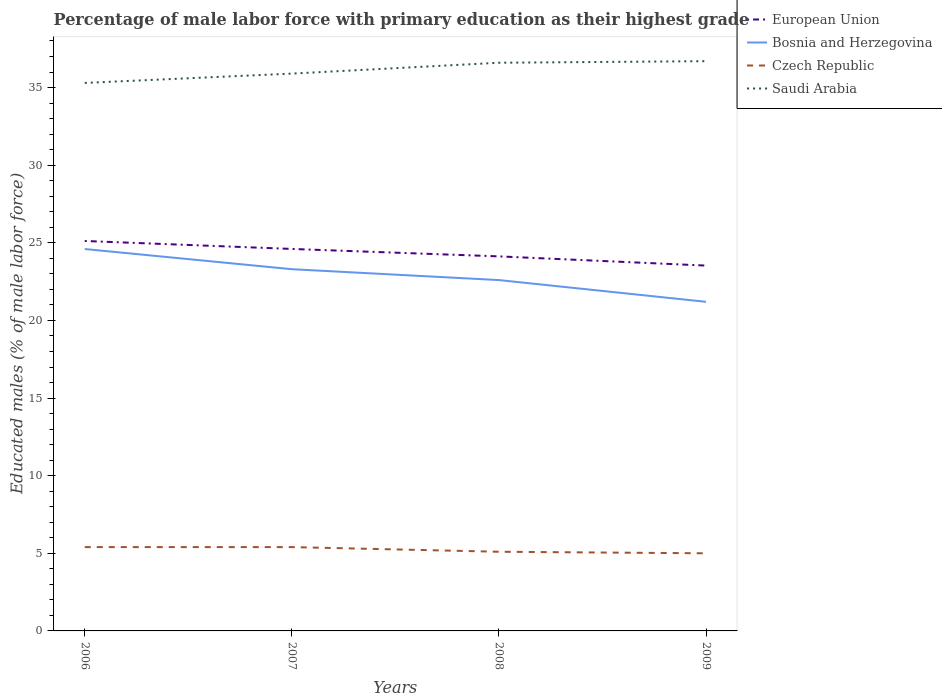How many different coloured lines are there?
Offer a terse response. 4. Across all years, what is the maximum percentage of male labor force with primary education in Bosnia and Herzegovina?
Ensure brevity in your answer.  21.2. In which year was the percentage of male labor force with primary education in European Union maximum?
Give a very brief answer. 2009. What is the total percentage of male labor force with primary education in Bosnia and Herzegovina in the graph?
Provide a short and direct response. 2.1. What is the difference between the highest and the second highest percentage of male labor force with primary education in European Union?
Offer a terse response. 1.59. What is the difference between the highest and the lowest percentage of male labor force with primary education in European Union?
Ensure brevity in your answer.  2. Is the percentage of male labor force with primary education in European Union strictly greater than the percentage of male labor force with primary education in Czech Republic over the years?
Make the answer very short. No. What is the title of the graph?
Offer a terse response. Percentage of male labor force with primary education as their highest grade. Does "Timor-Leste" appear as one of the legend labels in the graph?
Offer a terse response. No. What is the label or title of the X-axis?
Your response must be concise. Years. What is the label or title of the Y-axis?
Offer a terse response. Educated males (% of male labor force). What is the Educated males (% of male labor force) in European Union in 2006?
Ensure brevity in your answer.  25.12. What is the Educated males (% of male labor force) of Bosnia and Herzegovina in 2006?
Provide a succinct answer. 24.6. What is the Educated males (% of male labor force) in Czech Republic in 2006?
Offer a terse response. 5.4. What is the Educated males (% of male labor force) of Saudi Arabia in 2006?
Offer a very short reply. 35.3. What is the Educated males (% of male labor force) of European Union in 2007?
Your response must be concise. 24.61. What is the Educated males (% of male labor force) in Bosnia and Herzegovina in 2007?
Your answer should be very brief. 23.3. What is the Educated males (% of male labor force) in Czech Republic in 2007?
Your answer should be very brief. 5.4. What is the Educated males (% of male labor force) in Saudi Arabia in 2007?
Provide a short and direct response. 35.9. What is the Educated males (% of male labor force) of European Union in 2008?
Keep it short and to the point. 24.13. What is the Educated males (% of male labor force) in Bosnia and Herzegovina in 2008?
Offer a terse response. 22.6. What is the Educated males (% of male labor force) of Czech Republic in 2008?
Provide a short and direct response. 5.1. What is the Educated males (% of male labor force) in Saudi Arabia in 2008?
Your answer should be compact. 36.6. What is the Educated males (% of male labor force) of European Union in 2009?
Offer a very short reply. 23.53. What is the Educated males (% of male labor force) of Bosnia and Herzegovina in 2009?
Make the answer very short. 21.2. What is the Educated males (% of male labor force) of Czech Republic in 2009?
Provide a succinct answer. 5. What is the Educated males (% of male labor force) of Saudi Arabia in 2009?
Keep it short and to the point. 36.7. Across all years, what is the maximum Educated males (% of male labor force) in European Union?
Your answer should be compact. 25.12. Across all years, what is the maximum Educated males (% of male labor force) in Bosnia and Herzegovina?
Offer a very short reply. 24.6. Across all years, what is the maximum Educated males (% of male labor force) of Czech Republic?
Your answer should be compact. 5.4. Across all years, what is the maximum Educated males (% of male labor force) in Saudi Arabia?
Provide a short and direct response. 36.7. Across all years, what is the minimum Educated males (% of male labor force) in European Union?
Keep it short and to the point. 23.53. Across all years, what is the minimum Educated males (% of male labor force) of Bosnia and Herzegovina?
Give a very brief answer. 21.2. Across all years, what is the minimum Educated males (% of male labor force) in Saudi Arabia?
Offer a very short reply. 35.3. What is the total Educated males (% of male labor force) of European Union in the graph?
Provide a short and direct response. 97.38. What is the total Educated males (% of male labor force) in Bosnia and Herzegovina in the graph?
Provide a short and direct response. 91.7. What is the total Educated males (% of male labor force) of Czech Republic in the graph?
Offer a very short reply. 20.9. What is the total Educated males (% of male labor force) of Saudi Arabia in the graph?
Offer a terse response. 144.5. What is the difference between the Educated males (% of male labor force) in European Union in 2006 and that in 2007?
Offer a very short reply. 0.51. What is the difference between the Educated males (% of male labor force) of Bosnia and Herzegovina in 2006 and that in 2007?
Offer a very short reply. 1.3. What is the difference between the Educated males (% of male labor force) in European Union in 2006 and that in 2008?
Keep it short and to the point. 0.99. What is the difference between the Educated males (% of male labor force) in Saudi Arabia in 2006 and that in 2008?
Provide a short and direct response. -1.3. What is the difference between the Educated males (% of male labor force) in European Union in 2006 and that in 2009?
Provide a succinct answer. 1.59. What is the difference between the Educated males (% of male labor force) in Bosnia and Herzegovina in 2006 and that in 2009?
Offer a very short reply. 3.4. What is the difference between the Educated males (% of male labor force) of Czech Republic in 2006 and that in 2009?
Provide a short and direct response. 0.4. What is the difference between the Educated males (% of male labor force) in Saudi Arabia in 2006 and that in 2009?
Offer a terse response. -1.4. What is the difference between the Educated males (% of male labor force) in European Union in 2007 and that in 2008?
Provide a succinct answer. 0.48. What is the difference between the Educated males (% of male labor force) of European Union in 2007 and that in 2009?
Provide a succinct answer. 1.07. What is the difference between the Educated males (% of male labor force) of Czech Republic in 2007 and that in 2009?
Make the answer very short. 0.4. What is the difference between the Educated males (% of male labor force) in European Union in 2008 and that in 2009?
Your answer should be very brief. 0.59. What is the difference between the Educated males (% of male labor force) of Bosnia and Herzegovina in 2008 and that in 2009?
Ensure brevity in your answer.  1.4. What is the difference between the Educated males (% of male labor force) in Czech Republic in 2008 and that in 2009?
Offer a very short reply. 0.1. What is the difference between the Educated males (% of male labor force) in European Union in 2006 and the Educated males (% of male labor force) in Bosnia and Herzegovina in 2007?
Keep it short and to the point. 1.82. What is the difference between the Educated males (% of male labor force) of European Union in 2006 and the Educated males (% of male labor force) of Czech Republic in 2007?
Offer a terse response. 19.72. What is the difference between the Educated males (% of male labor force) of European Union in 2006 and the Educated males (% of male labor force) of Saudi Arabia in 2007?
Your response must be concise. -10.78. What is the difference between the Educated males (% of male labor force) in Czech Republic in 2006 and the Educated males (% of male labor force) in Saudi Arabia in 2007?
Offer a terse response. -30.5. What is the difference between the Educated males (% of male labor force) of European Union in 2006 and the Educated males (% of male labor force) of Bosnia and Herzegovina in 2008?
Provide a succinct answer. 2.52. What is the difference between the Educated males (% of male labor force) in European Union in 2006 and the Educated males (% of male labor force) in Czech Republic in 2008?
Your response must be concise. 20.02. What is the difference between the Educated males (% of male labor force) of European Union in 2006 and the Educated males (% of male labor force) of Saudi Arabia in 2008?
Give a very brief answer. -11.48. What is the difference between the Educated males (% of male labor force) in Bosnia and Herzegovina in 2006 and the Educated males (% of male labor force) in Czech Republic in 2008?
Offer a terse response. 19.5. What is the difference between the Educated males (% of male labor force) of Czech Republic in 2006 and the Educated males (% of male labor force) of Saudi Arabia in 2008?
Keep it short and to the point. -31.2. What is the difference between the Educated males (% of male labor force) in European Union in 2006 and the Educated males (% of male labor force) in Bosnia and Herzegovina in 2009?
Provide a short and direct response. 3.92. What is the difference between the Educated males (% of male labor force) of European Union in 2006 and the Educated males (% of male labor force) of Czech Republic in 2009?
Provide a short and direct response. 20.12. What is the difference between the Educated males (% of male labor force) of European Union in 2006 and the Educated males (% of male labor force) of Saudi Arabia in 2009?
Provide a succinct answer. -11.58. What is the difference between the Educated males (% of male labor force) in Bosnia and Herzegovina in 2006 and the Educated males (% of male labor force) in Czech Republic in 2009?
Make the answer very short. 19.6. What is the difference between the Educated males (% of male labor force) of Bosnia and Herzegovina in 2006 and the Educated males (% of male labor force) of Saudi Arabia in 2009?
Keep it short and to the point. -12.1. What is the difference between the Educated males (% of male labor force) in Czech Republic in 2006 and the Educated males (% of male labor force) in Saudi Arabia in 2009?
Your answer should be compact. -31.3. What is the difference between the Educated males (% of male labor force) of European Union in 2007 and the Educated males (% of male labor force) of Bosnia and Herzegovina in 2008?
Keep it short and to the point. 2.01. What is the difference between the Educated males (% of male labor force) in European Union in 2007 and the Educated males (% of male labor force) in Czech Republic in 2008?
Provide a succinct answer. 19.51. What is the difference between the Educated males (% of male labor force) of European Union in 2007 and the Educated males (% of male labor force) of Saudi Arabia in 2008?
Make the answer very short. -11.99. What is the difference between the Educated males (% of male labor force) of Bosnia and Herzegovina in 2007 and the Educated males (% of male labor force) of Czech Republic in 2008?
Keep it short and to the point. 18.2. What is the difference between the Educated males (% of male labor force) in Czech Republic in 2007 and the Educated males (% of male labor force) in Saudi Arabia in 2008?
Your answer should be very brief. -31.2. What is the difference between the Educated males (% of male labor force) of European Union in 2007 and the Educated males (% of male labor force) of Bosnia and Herzegovina in 2009?
Your answer should be very brief. 3.41. What is the difference between the Educated males (% of male labor force) of European Union in 2007 and the Educated males (% of male labor force) of Czech Republic in 2009?
Give a very brief answer. 19.61. What is the difference between the Educated males (% of male labor force) of European Union in 2007 and the Educated males (% of male labor force) of Saudi Arabia in 2009?
Make the answer very short. -12.09. What is the difference between the Educated males (% of male labor force) in Bosnia and Herzegovina in 2007 and the Educated males (% of male labor force) in Czech Republic in 2009?
Your response must be concise. 18.3. What is the difference between the Educated males (% of male labor force) of Czech Republic in 2007 and the Educated males (% of male labor force) of Saudi Arabia in 2009?
Your response must be concise. -31.3. What is the difference between the Educated males (% of male labor force) in European Union in 2008 and the Educated males (% of male labor force) in Bosnia and Herzegovina in 2009?
Your answer should be compact. 2.93. What is the difference between the Educated males (% of male labor force) in European Union in 2008 and the Educated males (% of male labor force) in Czech Republic in 2009?
Your response must be concise. 19.13. What is the difference between the Educated males (% of male labor force) in European Union in 2008 and the Educated males (% of male labor force) in Saudi Arabia in 2009?
Your response must be concise. -12.57. What is the difference between the Educated males (% of male labor force) in Bosnia and Herzegovina in 2008 and the Educated males (% of male labor force) in Saudi Arabia in 2009?
Offer a very short reply. -14.1. What is the difference between the Educated males (% of male labor force) in Czech Republic in 2008 and the Educated males (% of male labor force) in Saudi Arabia in 2009?
Keep it short and to the point. -31.6. What is the average Educated males (% of male labor force) of European Union per year?
Your answer should be very brief. 24.35. What is the average Educated males (% of male labor force) of Bosnia and Herzegovina per year?
Keep it short and to the point. 22.93. What is the average Educated males (% of male labor force) of Czech Republic per year?
Provide a succinct answer. 5.22. What is the average Educated males (% of male labor force) in Saudi Arabia per year?
Provide a short and direct response. 36.12. In the year 2006, what is the difference between the Educated males (% of male labor force) of European Union and Educated males (% of male labor force) of Bosnia and Herzegovina?
Offer a very short reply. 0.52. In the year 2006, what is the difference between the Educated males (% of male labor force) of European Union and Educated males (% of male labor force) of Czech Republic?
Make the answer very short. 19.72. In the year 2006, what is the difference between the Educated males (% of male labor force) in European Union and Educated males (% of male labor force) in Saudi Arabia?
Give a very brief answer. -10.18. In the year 2006, what is the difference between the Educated males (% of male labor force) in Bosnia and Herzegovina and Educated males (% of male labor force) in Saudi Arabia?
Your answer should be very brief. -10.7. In the year 2006, what is the difference between the Educated males (% of male labor force) in Czech Republic and Educated males (% of male labor force) in Saudi Arabia?
Provide a succinct answer. -29.9. In the year 2007, what is the difference between the Educated males (% of male labor force) in European Union and Educated males (% of male labor force) in Bosnia and Herzegovina?
Keep it short and to the point. 1.31. In the year 2007, what is the difference between the Educated males (% of male labor force) in European Union and Educated males (% of male labor force) in Czech Republic?
Your response must be concise. 19.21. In the year 2007, what is the difference between the Educated males (% of male labor force) of European Union and Educated males (% of male labor force) of Saudi Arabia?
Your answer should be compact. -11.29. In the year 2007, what is the difference between the Educated males (% of male labor force) of Bosnia and Herzegovina and Educated males (% of male labor force) of Saudi Arabia?
Make the answer very short. -12.6. In the year 2007, what is the difference between the Educated males (% of male labor force) of Czech Republic and Educated males (% of male labor force) of Saudi Arabia?
Keep it short and to the point. -30.5. In the year 2008, what is the difference between the Educated males (% of male labor force) in European Union and Educated males (% of male labor force) in Bosnia and Herzegovina?
Your response must be concise. 1.53. In the year 2008, what is the difference between the Educated males (% of male labor force) of European Union and Educated males (% of male labor force) of Czech Republic?
Keep it short and to the point. 19.03. In the year 2008, what is the difference between the Educated males (% of male labor force) of European Union and Educated males (% of male labor force) of Saudi Arabia?
Ensure brevity in your answer.  -12.47. In the year 2008, what is the difference between the Educated males (% of male labor force) of Bosnia and Herzegovina and Educated males (% of male labor force) of Saudi Arabia?
Ensure brevity in your answer.  -14. In the year 2008, what is the difference between the Educated males (% of male labor force) of Czech Republic and Educated males (% of male labor force) of Saudi Arabia?
Keep it short and to the point. -31.5. In the year 2009, what is the difference between the Educated males (% of male labor force) of European Union and Educated males (% of male labor force) of Bosnia and Herzegovina?
Your response must be concise. 2.33. In the year 2009, what is the difference between the Educated males (% of male labor force) in European Union and Educated males (% of male labor force) in Czech Republic?
Give a very brief answer. 18.53. In the year 2009, what is the difference between the Educated males (% of male labor force) of European Union and Educated males (% of male labor force) of Saudi Arabia?
Make the answer very short. -13.17. In the year 2009, what is the difference between the Educated males (% of male labor force) in Bosnia and Herzegovina and Educated males (% of male labor force) in Saudi Arabia?
Give a very brief answer. -15.5. In the year 2009, what is the difference between the Educated males (% of male labor force) in Czech Republic and Educated males (% of male labor force) in Saudi Arabia?
Keep it short and to the point. -31.7. What is the ratio of the Educated males (% of male labor force) of European Union in 2006 to that in 2007?
Your response must be concise. 1.02. What is the ratio of the Educated males (% of male labor force) in Bosnia and Herzegovina in 2006 to that in 2007?
Your response must be concise. 1.06. What is the ratio of the Educated males (% of male labor force) of Czech Republic in 2006 to that in 2007?
Make the answer very short. 1. What is the ratio of the Educated males (% of male labor force) of Saudi Arabia in 2006 to that in 2007?
Make the answer very short. 0.98. What is the ratio of the Educated males (% of male labor force) of European Union in 2006 to that in 2008?
Offer a very short reply. 1.04. What is the ratio of the Educated males (% of male labor force) of Bosnia and Herzegovina in 2006 to that in 2008?
Provide a succinct answer. 1.09. What is the ratio of the Educated males (% of male labor force) in Czech Republic in 2006 to that in 2008?
Make the answer very short. 1.06. What is the ratio of the Educated males (% of male labor force) in Saudi Arabia in 2006 to that in 2008?
Keep it short and to the point. 0.96. What is the ratio of the Educated males (% of male labor force) of European Union in 2006 to that in 2009?
Ensure brevity in your answer.  1.07. What is the ratio of the Educated males (% of male labor force) of Bosnia and Herzegovina in 2006 to that in 2009?
Your answer should be compact. 1.16. What is the ratio of the Educated males (% of male labor force) in Saudi Arabia in 2006 to that in 2009?
Give a very brief answer. 0.96. What is the ratio of the Educated males (% of male labor force) in European Union in 2007 to that in 2008?
Offer a terse response. 1.02. What is the ratio of the Educated males (% of male labor force) in Bosnia and Herzegovina in 2007 to that in 2008?
Offer a terse response. 1.03. What is the ratio of the Educated males (% of male labor force) of Czech Republic in 2007 to that in 2008?
Provide a short and direct response. 1.06. What is the ratio of the Educated males (% of male labor force) in Saudi Arabia in 2007 to that in 2008?
Make the answer very short. 0.98. What is the ratio of the Educated males (% of male labor force) in European Union in 2007 to that in 2009?
Offer a terse response. 1.05. What is the ratio of the Educated males (% of male labor force) of Bosnia and Herzegovina in 2007 to that in 2009?
Offer a very short reply. 1.1. What is the ratio of the Educated males (% of male labor force) of Czech Republic in 2007 to that in 2009?
Offer a terse response. 1.08. What is the ratio of the Educated males (% of male labor force) of Saudi Arabia in 2007 to that in 2009?
Offer a terse response. 0.98. What is the ratio of the Educated males (% of male labor force) of European Union in 2008 to that in 2009?
Give a very brief answer. 1.03. What is the ratio of the Educated males (% of male labor force) in Bosnia and Herzegovina in 2008 to that in 2009?
Give a very brief answer. 1.07. What is the ratio of the Educated males (% of male labor force) in Saudi Arabia in 2008 to that in 2009?
Keep it short and to the point. 1. What is the difference between the highest and the second highest Educated males (% of male labor force) in European Union?
Your answer should be very brief. 0.51. What is the difference between the highest and the second highest Educated males (% of male labor force) of Bosnia and Herzegovina?
Provide a short and direct response. 1.3. What is the difference between the highest and the second highest Educated males (% of male labor force) in Czech Republic?
Your response must be concise. 0. What is the difference between the highest and the second highest Educated males (% of male labor force) in Saudi Arabia?
Provide a succinct answer. 0.1. What is the difference between the highest and the lowest Educated males (% of male labor force) of European Union?
Provide a short and direct response. 1.59. What is the difference between the highest and the lowest Educated males (% of male labor force) in Czech Republic?
Keep it short and to the point. 0.4. What is the difference between the highest and the lowest Educated males (% of male labor force) of Saudi Arabia?
Your response must be concise. 1.4. 